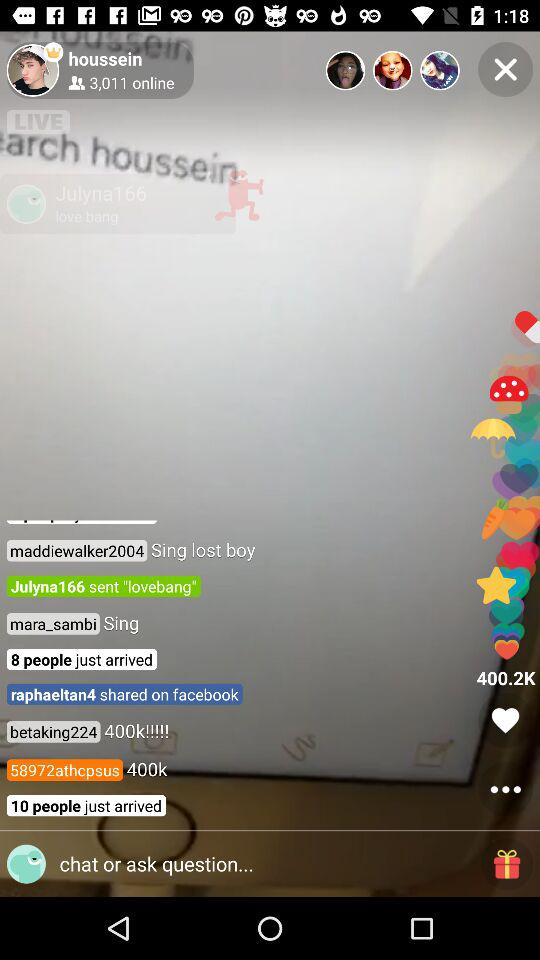How many likes are there on the live stream? The number of likes is 400.2K. 